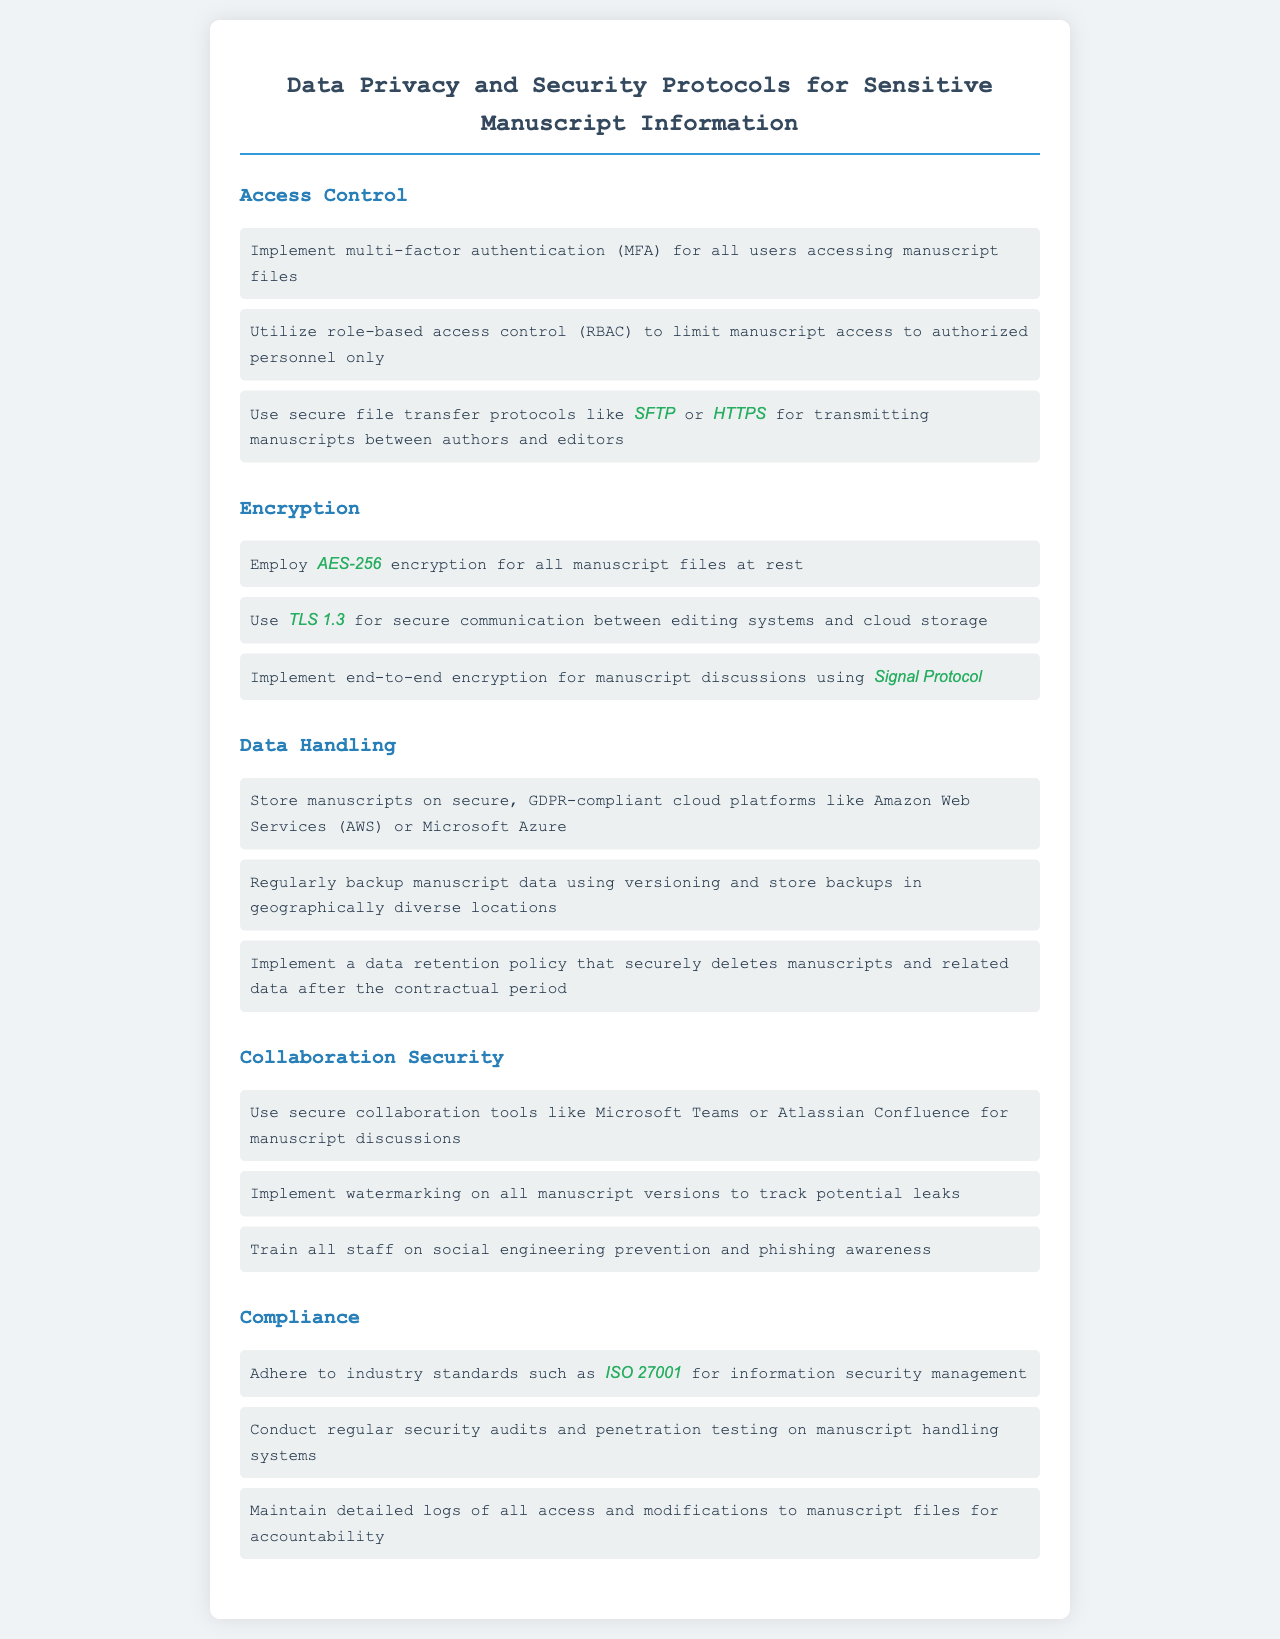What are the two protocols suggested for transmitting manuscripts? The document specifies using secure file transfer protocols like SFTP or HTTPS for transmitting manuscripts between authors and editors.
Answer: SFTP, HTTPS What encryption standard should be used for manuscript files at rest? The document states that AES-256 encryption should be employed for all manuscript files at rest.
Answer: AES-256 Which cloud platforms are recommended for manuscript storage? According to the document, manuscripts should be stored on secure, GDPR-compliant cloud platforms like Amazon Web Services or Microsoft Azure.
Answer: Amazon Web Services, Microsoft Azure How many types of access control methods are mentioned in the document? The document details three access control methods: multi-factor authentication, role-based access control, and secure file transfer protocols.
Answer: Three What document type standard compliance is mentioned? The document references adherence to industry standards such as ISO 27001 for information security management.
Answer: ISO 27001 What is the purpose of watermarking on manuscript versions? The document indicates that watermarking is used to track potential leaks of manuscript versions.
Answer: Track potential leaks Which encryption protocol is mentioned for secure communication? The document specifies using TLS 1.3 for secure communication between editing systems and cloud storage.
Answer: TLS 1.3 How often should security audits be conducted? The document emphasizes conducting regular security audits on manuscript handling systems.
Answer: Regularly What type of training should staff receive? The document states that all staff should be trained on social engineering prevention and phishing awareness.
Answer: Social engineering prevention and phishing awareness 